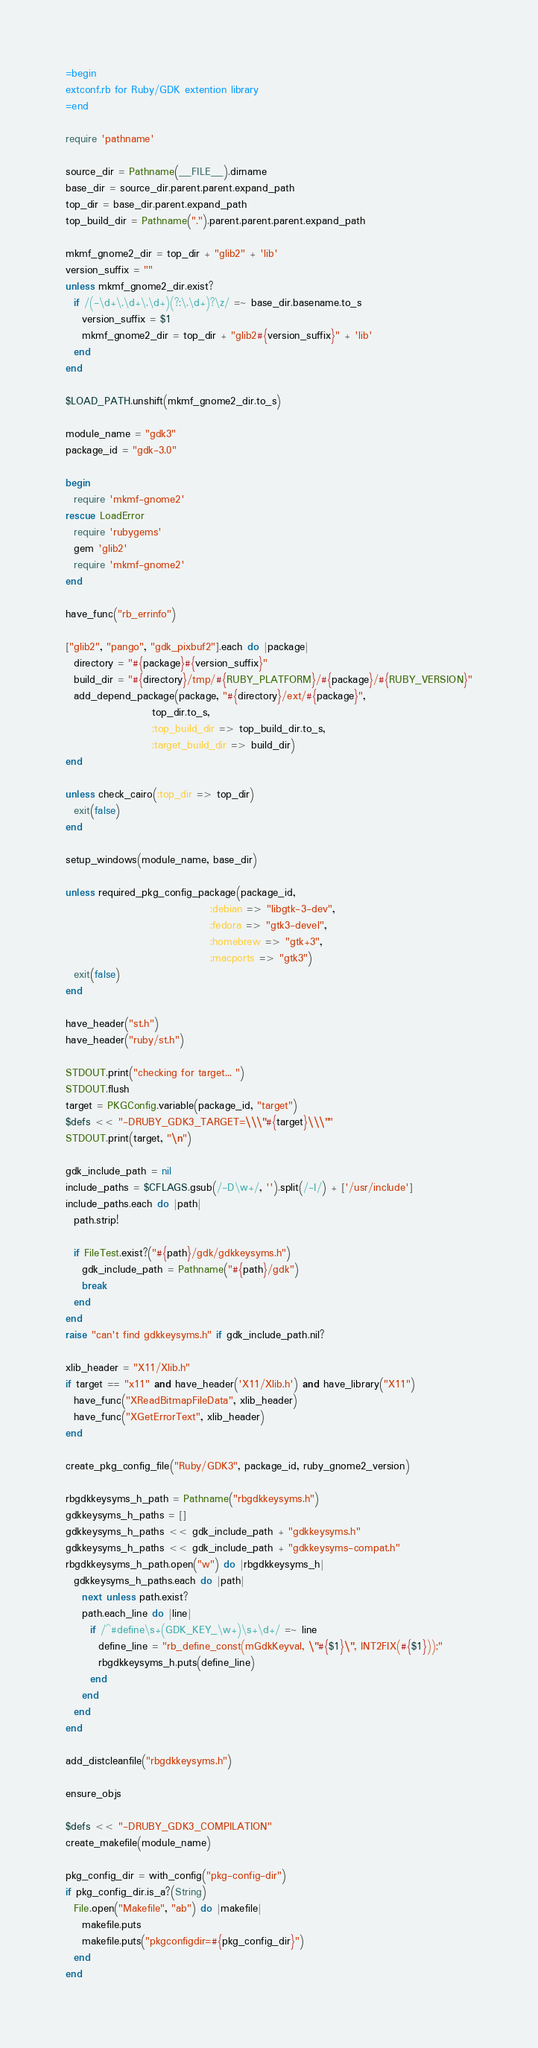<code> <loc_0><loc_0><loc_500><loc_500><_Ruby_>=begin
extconf.rb for Ruby/GDK extention library
=end

require 'pathname'

source_dir = Pathname(__FILE__).dirname
base_dir = source_dir.parent.parent.expand_path
top_dir = base_dir.parent.expand_path
top_build_dir = Pathname(".").parent.parent.parent.expand_path

mkmf_gnome2_dir = top_dir + "glib2" + 'lib'
version_suffix = ""
unless mkmf_gnome2_dir.exist?
  if /(-\d+\.\d+\.\d+)(?:\.\d+)?\z/ =~ base_dir.basename.to_s
    version_suffix = $1
    mkmf_gnome2_dir = top_dir + "glib2#{version_suffix}" + 'lib'
  end
end

$LOAD_PATH.unshift(mkmf_gnome2_dir.to_s)

module_name = "gdk3"
package_id = "gdk-3.0"

begin
  require 'mkmf-gnome2'
rescue LoadError
  require 'rubygems'
  gem 'glib2'
  require 'mkmf-gnome2'
end

have_func("rb_errinfo")

["glib2", "pango", "gdk_pixbuf2"].each do |package|
  directory = "#{package}#{version_suffix}"
  build_dir = "#{directory}/tmp/#{RUBY_PLATFORM}/#{package}/#{RUBY_VERSION}"
  add_depend_package(package, "#{directory}/ext/#{package}",
                     top_dir.to_s,
                     :top_build_dir => top_build_dir.to_s,
                     :target_build_dir => build_dir)
end

unless check_cairo(:top_dir => top_dir)
  exit(false)
end

setup_windows(module_name, base_dir)

unless required_pkg_config_package(package_id,
                                   :debian => "libgtk-3-dev",
                                   :fedora => "gtk3-devel",
                                   :homebrew => "gtk+3",
                                   :macports => "gtk3")
  exit(false)
end

have_header("st.h")
have_header("ruby/st.h")

STDOUT.print("checking for target... ")
STDOUT.flush
target = PKGConfig.variable(package_id, "target")
$defs << "-DRUBY_GDK3_TARGET=\\\"#{target}\\\""
STDOUT.print(target, "\n")

gdk_include_path = nil
include_paths = $CFLAGS.gsub(/-D\w+/, '').split(/-I/) + ['/usr/include']
include_paths.each do |path|
  path.strip!

  if FileTest.exist?("#{path}/gdk/gdkkeysyms.h")
    gdk_include_path = Pathname("#{path}/gdk")
    break
  end
end
raise "can't find gdkkeysyms.h" if gdk_include_path.nil?

xlib_header = "X11/Xlib.h"
if target == "x11" and have_header('X11/Xlib.h') and have_library("X11")
  have_func("XReadBitmapFileData", xlib_header)
  have_func("XGetErrorText", xlib_header)
end

create_pkg_config_file("Ruby/GDK3", package_id, ruby_gnome2_version)

rbgdkkeysyms_h_path = Pathname("rbgdkkeysyms.h")
gdkkeysyms_h_paths = []
gdkkeysyms_h_paths << gdk_include_path + "gdkkeysyms.h"
gdkkeysyms_h_paths << gdk_include_path + "gdkkeysyms-compat.h"
rbgdkkeysyms_h_path.open("w") do |rbgdkkeysyms_h|
  gdkkeysyms_h_paths.each do |path|
    next unless path.exist?
    path.each_line do |line|
      if /^#define\s+(GDK_KEY_\w+)\s+\d+/ =~ line
        define_line = "rb_define_const(mGdkKeyval, \"#{$1}\", INT2FIX(#{$1}));"
        rbgdkkeysyms_h.puts(define_line)
      end
    end
  end
end

add_distcleanfile("rbgdkkeysyms.h")

ensure_objs

$defs << "-DRUBY_GDK3_COMPILATION"
create_makefile(module_name)

pkg_config_dir = with_config("pkg-config-dir")
if pkg_config_dir.is_a?(String)
  File.open("Makefile", "ab") do |makefile|
    makefile.puts
    makefile.puts("pkgconfigdir=#{pkg_config_dir}")
  end
end
</code> 